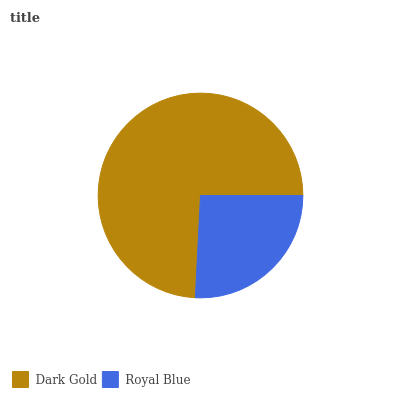Is Royal Blue the minimum?
Answer yes or no. Yes. Is Dark Gold the maximum?
Answer yes or no. Yes. Is Royal Blue the maximum?
Answer yes or no. No. Is Dark Gold greater than Royal Blue?
Answer yes or no. Yes. Is Royal Blue less than Dark Gold?
Answer yes or no. Yes. Is Royal Blue greater than Dark Gold?
Answer yes or no. No. Is Dark Gold less than Royal Blue?
Answer yes or no. No. Is Dark Gold the high median?
Answer yes or no. Yes. Is Royal Blue the low median?
Answer yes or no. Yes. Is Royal Blue the high median?
Answer yes or no. No. Is Dark Gold the low median?
Answer yes or no. No. 